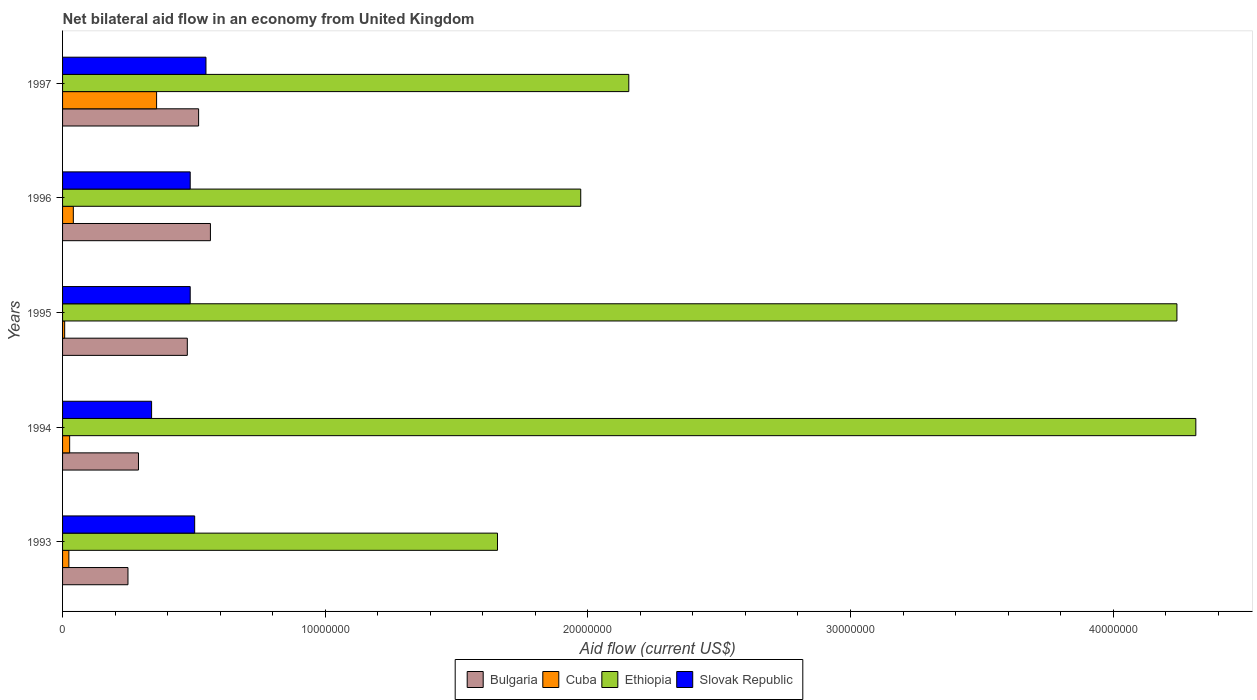How many different coloured bars are there?
Provide a short and direct response. 4. How many groups of bars are there?
Provide a succinct answer. 5. In how many cases, is the number of bars for a given year not equal to the number of legend labels?
Offer a terse response. 0. What is the net bilateral aid flow in Bulgaria in 1994?
Keep it short and to the point. 2.89e+06. Across all years, what is the maximum net bilateral aid flow in Bulgaria?
Offer a terse response. 5.63e+06. Across all years, what is the minimum net bilateral aid flow in Slovak Republic?
Make the answer very short. 3.39e+06. In which year was the net bilateral aid flow in Slovak Republic maximum?
Make the answer very short. 1997. In which year was the net bilateral aid flow in Bulgaria minimum?
Ensure brevity in your answer.  1993. What is the total net bilateral aid flow in Cuba in the graph?
Make the answer very short. 4.58e+06. What is the difference between the net bilateral aid flow in Ethiopia in 1995 and that in 1997?
Offer a very short reply. 2.09e+07. What is the difference between the net bilateral aid flow in Cuba in 1997 and the net bilateral aid flow in Slovak Republic in 1995?
Offer a terse response. -1.28e+06. What is the average net bilateral aid flow in Slovak Republic per year?
Your answer should be very brief. 4.72e+06. In the year 1996, what is the difference between the net bilateral aid flow in Ethiopia and net bilateral aid flow in Cuba?
Provide a succinct answer. 1.93e+07. In how many years, is the net bilateral aid flow in Cuba greater than 36000000 US$?
Offer a very short reply. 0. What is the ratio of the net bilateral aid flow in Ethiopia in 1994 to that in 1997?
Your answer should be very brief. 2. Is the difference between the net bilateral aid flow in Ethiopia in 1994 and 1997 greater than the difference between the net bilateral aid flow in Cuba in 1994 and 1997?
Provide a succinct answer. Yes. What is the difference between the highest and the second highest net bilateral aid flow in Cuba?
Offer a very short reply. 3.17e+06. What is the difference between the highest and the lowest net bilateral aid flow in Slovak Republic?
Your answer should be compact. 2.07e+06. In how many years, is the net bilateral aid flow in Bulgaria greater than the average net bilateral aid flow in Bulgaria taken over all years?
Make the answer very short. 3. What does the 3rd bar from the top in 1993 represents?
Ensure brevity in your answer.  Cuba. What does the 4th bar from the bottom in 1995 represents?
Provide a succinct answer. Slovak Republic. Is it the case that in every year, the sum of the net bilateral aid flow in Cuba and net bilateral aid flow in Bulgaria is greater than the net bilateral aid flow in Ethiopia?
Your answer should be compact. No. Are all the bars in the graph horizontal?
Keep it short and to the point. Yes. How many years are there in the graph?
Keep it short and to the point. 5. What is the difference between two consecutive major ticks on the X-axis?
Provide a short and direct response. 1.00e+07. Does the graph contain grids?
Give a very brief answer. No. Where does the legend appear in the graph?
Your answer should be compact. Bottom center. What is the title of the graph?
Provide a short and direct response. Net bilateral aid flow in an economy from United Kingdom. Does "East Asia (developing only)" appear as one of the legend labels in the graph?
Keep it short and to the point. No. What is the label or title of the X-axis?
Provide a short and direct response. Aid flow (current US$). What is the Aid flow (current US$) of Bulgaria in 1993?
Give a very brief answer. 2.49e+06. What is the Aid flow (current US$) of Ethiopia in 1993?
Offer a terse response. 1.66e+07. What is the Aid flow (current US$) of Slovak Republic in 1993?
Give a very brief answer. 5.03e+06. What is the Aid flow (current US$) of Bulgaria in 1994?
Ensure brevity in your answer.  2.89e+06. What is the Aid flow (current US$) of Ethiopia in 1994?
Offer a terse response. 4.32e+07. What is the Aid flow (current US$) in Slovak Republic in 1994?
Provide a short and direct response. 3.39e+06. What is the Aid flow (current US$) of Bulgaria in 1995?
Offer a terse response. 4.75e+06. What is the Aid flow (current US$) of Ethiopia in 1995?
Your response must be concise. 4.24e+07. What is the Aid flow (current US$) in Slovak Republic in 1995?
Provide a short and direct response. 4.86e+06. What is the Aid flow (current US$) in Bulgaria in 1996?
Provide a succinct answer. 5.63e+06. What is the Aid flow (current US$) in Ethiopia in 1996?
Your answer should be very brief. 1.97e+07. What is the Aid flow (current US$) in Slovak Republic in 1996?
Offer a very short reply. 4.86e+06. What is the Aid flow (current US$) in Bulgaria in 1997?
Give a very brief answer. 5.18e+06. What is the Aid flow (current US$) in Cuba in 1997?
Ensure brevity in your answer.  3.58e+06. What is the Aid flow (current US$) in Ethiopia in 1997?
Provide a succinct answer. 2.16e+07. What is the Aid flow (current US$) in Slovak Republic in 1997?
Your response must be concise. 5.46e+06. Across all years, what is the maximum Aid flow (current US$) in Bulgaria?
Offer a very short reply. 5.63e+06. Across all years, what is the maximum Aid flow (current US$) of Cuba?
Offer a very short reply. 3.58e+06. Across all years, what is the maximum Aid flow (current US$) of Ethiopia?
Make the answer very short. 4.32e+07. Across all years, what is the maximum Aid flow (current US$) in Slovak Republic?
Keep it short and to the point. 5.46e+06. Across all years, what is the minimum Aid flow (current US$) in Bulgaria?
Keep it short and to the point. 2.49e+06. Across all years, what is the minimum Aid flow (current US$) of Cuba?
Your answer should be compact. 8.00e+04. Across all years, what is the minimum Aid flow (current US$) in Ethiopia?
Your answer should be compact. 1.66e+07. Across all years, what is the minimum Aid flow (current US$) of Slovak Republic?
Provide a short and direct response. 3.39e+06. What is the total Aid flow (current US$) of Bulgaria in the graph?
Give a very brief answer. 2.09e+07. What is the total Aid flow (current US$) in Cuba in the graph?
Your answer should be compact. 4.58e+06. What is the total Aid flow (current US$) of Ethiopia in the graph?
Give a very brief answer. 1.43e+08. What is the total Aid flow (current US$) in Slovak Republic in the graph?
Give a very brief answer. 2.36e+07. What is the difference between the Aid flow (current US$) in Bulgaria in 1993 and that in 1994?
Your response must be concise. -4.00e+05. What is the difference between the Aid flow (current US$) in Ethiopia in 1993 and that in 1994?
Keep it short and to the point. -2.66e+07. What is the difference between the Aid flow (current US$) in Slovak Republic in 1993 and that in 1994?
Offer a very short reply. 1.64e+06. What is the difference between the Aid flow (current US$) in Bulgaria in 1993 and that in 1995?
Ensure brevity in your answer.  -2.26e+06. What is the difference between the Aid flow (current US$) of Ethiopia in 1993 and that in 1995?
Give a very brief answer. -2.59e+07. What is the difference between the Aid flow (current US$) in Slovak Republic in 1993 and that in 1995?
Your response must be concise. 1.70e+05. What is the difference between the Aid flow (current US$) in Bulgaria in 1993 and that in 1996?
Ensure brevity in your answer.  -3.14e+06. What is the difference between the Aid flow (current US$) of Ethiopia in 1993 and that in 1996?
Offer a very short reply. -3.17e+06. What is the difference between the Aid flow (current US$) of Bulgaria in 1993 and that in 1997?
Provide a succinct answer. -2.69e+06. What is the difference between the Aid flow (current US$) in Cuba in 1993 and that in 1997?
Provide a succinct answer. -3.34e+06. What is the difference between the Aid flow (current US$) of Ethiopia in 1993 and that in 1997?
Offer a very short reply. -5.00e+06. What is the difference between the Aid flow (current US$) of Slovak Republic in 1993 and that in 1997?
Your answer should be very brief. -4.30e+05. What is the difference between the Aid flow (current US$) in Bulgaria in 1994 and that in 1995?
Keep it short and to the point. -1.86e+06. What is the difference between the Aid flow (current US$) of Cuba in 1994 and that in 1995?
Provide a short and direct response. 1.90e+05. What is the difference between the Aid flow (current US$) of Ethiopia in 1994 and that in 1995?
Give a very brief answer. 7.20e+05. What is the difference between the Aid flow (current US$) of Slovak Republic in 1994 and that in 1995?
Keep it short and to the point. -1.47e+06. What is the difference between the Aid flow (current US$) in Bulgaria in 1994 and that in 1996?
Keep it short and to the point. -2.74e+06. What is the difference between the Aid flow (current US$) of Cuba in 1994 and that in 1996?
Your answer should be compact. -1.40e+05. What is the difference between the Aid flow (current US$) of Ethiopia in 1994 and that in 1996?
Give a very brief answer. 2.34e+07. What is the difference between the Aid flow (current US$) in Slovak Republic in 1994 and that in 1996?
Your response must be concise. -1.47e+06. What is the difference between the Aid flow (current US$) of Bulgaria in 1994 and that in 1997?
Your response must be concise. -2.29e+06. What is the difference between the Aid flow (current US$) of Cuba in 1994 and that in 1997?
Offer a very short reply. -3.31e+06. What is the difference between the Aid flow (current US$) in Ethiopia in 1994 and that in 1997?
Keep it short and to the point. 2.16e+07. What is the difference between the Aid flow (current US$) of Slovak Republic in 1994 and that in 1997?
Ensure brevity in your answer.  -2.07e+06. What is the difference between the Aid flow (current US$) in Bulgaria in 1995 and that in 1996?
Provide a short and direct response. -8.80e+05. What is the difference between the Aid flow (current US$) in Cuba in 1995 and that in 1996?
Provide a succinct answer. -3.30e+05. What is the difference between the Aid flow (current US$) of Ethiopia in 1995 and that in 1996?
Your response must be concise. 2.27e+07. What is the difference between the Aid flow (current US$) of Bulgaria in 1995 and that in 1997?
Provide a short and direct response. -4.30e+05. What is the difference between the Aid flow (current US$) of Cuba in 1995 and that in 1997?
Provide a short and direct response. -3.50e+06. What is the difference between the Aid flow (current US$) of Ethiopia in 1995 and that in 1997?
Your response must be concise. 2.09e+07. What is the difference between the Aid flow (current US$) in Slovak Republic in 1995 and that in 1997?
Provide a short and direct response. -6.00e+05. What is the difference between the Aid flow (current US$) in Bulgaria in 1996 and that in 1997?
Offer a very short reply. 4.50e+05. What is the difference between the Aid flow (current US$) in Cuba in 1996 and that in 1997?
Your response must be concise. -3.17e+06. What is the difference between the Aid flow (current US$) of Ethiopia in 1996 and that in 1997?
Offer a very short reply. -1.83e+06. What is the difference between the Aid flow (current US$) in Slovak Republic in 1996 and that in 1997?
Offer a terse response. -6.00e+05. What is the difference between the Aid flow (current US$) in Bulgaria in 1993 and the Aid flow (current US$) in Cuba in 1994?
Give a very brief answer. 2.22e+06. What is the difference between the Aid flow (current US$) of Bulgaria in 1993 and the Aid flow (current US$) of Ethiopia in 1994?
Provide a short and direct response. -4.07e+07. What is the difference between the Aid flow (current US$) in Bulgaria in 1993 and the Aid flow (current US$) in Slovak Republic in 1994?
Your answer should be compact. -9.00e+05. What is the difference between the Aid flow (current US$) of Cuba in 1993 and the Aid flow (current US$) of Ethiopia in 1994?
Offer a terse response. -4.29e+07. What is the difference between the Aid flow (current US$) in Cuba in 1993 and the Aid flow (current US$) in Slovak Republic in 1994?
Offer a very short reply. -3.15e+06. What is the difference between the Aid flow (current US$) of Ethiopia in 1993 and the Aid flow (current US$) of Slovak Republic in 1994?
Offer a very short reply. 1.32e+07. What is the difference between the Aid flow (current US$) of Bulgaria in 1993 and the Aid flow (current US$) of Cuba in 1995?
Make the answer very short. 2.41e+06. What is the difference between the Aid flow (current US$) in Bulgaria in 1993 and the Aid flow (current US$) in Ethiopia in 1995?
Provide a succinct answer. -3.99e+07. What is the difference between the Aid flow (current US$) of Bulgaria in 1993 and the Aid flow (current US$) of Slovak Republic in 1995?
Your response must be concise. -2.37e+06. What is the difference between the Aid flow (current US$) of Cuba in 1993 and the Aid flow (current US$) of Ethiopia in 1995?
Offer a terse response. -4.22e+07. What is the difference between the Aid flow (current US$) in Cuba in 1993 and the Aid flow (current US$) in Slovak Republic in 1995?
Give a very brief answer. -4.62e+06. What is the difference between the Aid flow (current US$) in Ethiopia in 1993 and the Aid flow (current US$) in Slovak Republic in 1995?
Your response must be concise. 1.17e+07. What is the difference between the Aid flow (current US$) in Bulgaria in 1993 and the Aid flow (current US$) in Cuba in 1996?
Ensure brevity in your answer.  2.08e+06. What is the difference between the Aid flow (current US$) in Bulgaria in 1993 and the Aid flow (current US$) in Ethiopia in 1996?
Provide a short and direct response. -1.72e+07. What is the difference between the Aid flow (current US$) in Bulgaria in 1993 and the Aid flow (current US$) in Slovak Republic in 1996?
Your response must be concise. -2.37e+06. What is the difference between the Aid flow (current US$) of Cuba in 1993 and the Aid flow (current US$) of Ethiopia in 1996?
Your answer should be compact. -1.95e+07. What is the difference between the Aid flow (current US$) in Cuba in 1993 and the Aid flow (current US$) in Slovak Republic in 1996?
Provide a short and direct response. -4.62e+06. What is the difference between the Aid flow (current US$) of Ethiopia in 1993 and the Aid flow (current US$) of Slovak Republic in 1996?
Make the answer very short. 1.17e+07. What is the difference between the Aid flow (current US$) in Bulgaria in 1993 and the Aid flow (current US$) in Cuba in 1997?
Provide a succinct answer. -1.09e+06. What is the difference between the Aid flow (current US$) in Bulgaria in 1993 and the Aid flow (current US$) in Ethiopia in 1997?
Your answer should be compact. -1.91e+07. What is the difference between the Aid flow (current US$) of Bulgaria in 1993 and the Aid flow (current US$) of Slovak Republic in 1997?
Provide a succinct answer. -2.97e+06. What is the difference between the Aid flow (current US$) of Cuba in 1993 and the Aid flow (current US$) of Ethiopia in 1997?
Your answer should be compact. -2.13e+07. What is the difference between the Aid flow (current US$) of Cuba in 1993 and the Aid flow (current US$) of Slovak Republic in 1997?
Your answer should be compact. -5.22e+06. What is the difference between the Aid flow (current US$) of Ethiopia in 1993 and the Aid flow (current US$) of Slovak Republic in 1997?
Offer a very short reply. 1.11e+07. What is the difference between the Aid flow (current US$) in Bulgaria in 1994 and the Aid flow (current US$) in Cuba in 1995?
Offer a very short reply. 2.81e+06. What is the difference between the Aid flow (current US$) of Bulgaria in 1994 and the Aid flow (current US$) of Ethiopia in 1995?
Provide a succinct answer. -3.95e+07. What is the difference between the Aid flow (current US$) of Bulgaria in 1994 and the Aid flow (current US$) of Slovak Republic in 1995?
Ensure brevity in your answer.  -1.97e+06. What is the difference between the Aid flow (current US$) of Cuba in 1994 and the Aid flow (current US$) of Ethiopia in 1995?
Make the answer very short. -4.22e+07. What is the difference between the Aid flow (current US$) in Cuba in 1994 and the Aid flow (current US$) in Slovak Republic in 1995?
Offer a terse response. -4.59e+06. What is the difference between the Aid flow (current US$) of Ethiopia in 1994 and the Aid flow (current US$) of Slovak Republic in 1995?
Your response must be concise. 3.83e+07. What is the difference between the Aid flow (current US$) in Bulgaria in 1994 and the Aid flow (current US$) in Cuba in 1996?
Provide a succinct answer. 2.48e+06. What is the difference between the Aid flow (current US$) of Bulgaria in 1994 and the Aid flow (current US$) of Ethiopia in 1996?
Make the answer very short. -1.68e+07. What is the difference between the Aid flow (current US$) in Bulgaria in 1994 and the Aid flow (current US$) in Slovak Republic in 1996?
Provide a short and direct response. -1.97e+06. What is the difference between the Aid flow (current US$) in Cuba in 1994 and the Aid flow (current US$) in Ethiopia in 1996?
Ensure brevity in your answer.  -1.95e+07. What is the difference between the Aid flow (current US$) in Cuba in 1994 and the Aid flow (current US$) in Slovak Republic in 1996?
Your answer should be very brief. -4.59e+06. What is the difference between the Aid flow (current US$) in Ethiopia in 1994 and the Aid flow (current US$) in Slovak Republic in 1996?
Ensure brevity in your answer.  3.83e+07. What is the difference between the Aid flow (current US$) in Bulgaria in 1994 and the Aid flow (current US$) in Cuba in 1997?
Provide a short and direct response. -6.90e+05. What is the difference between the Aid flow (current US$) in Bulgaria in 1994 and the Aid flow (current US$) in Ethiopia in 1997?
Provide a succinct answer. -1.87e+07. What is the difference between the Aid flow (current US$) in Bulgaria in 1994 and the Aid flow (current US$) in Slovak Republic in 1997?
Your answer should be compact. -2.57e+06. What is the difference between the Aid flow (current US$) in Cuba in 1994 and the Aid flow (current US$) in Ethiopia in 1997?
Provide a succinct answer. -2.13e+07. What is the difference between the Aid flow (current US$) of Cuba in 1994 and the Aid flow (current US$) of Slovak Republic in 1997?
Your response must be concise. -5.19e+06. What is the difference between the Aid flow (current US$) in Ethiopia in 1994 and the Aid flow (current US$) in Slovak Republic in 1997?
Make the answer very short. 3.77e+07. What is the difference between the Aid flow (current US$) in Bulgaria in 1995 and the Aid flow (current US$) in Cuba in 1996?
Offer a terse response. 4.34e+06. What is the difference between the Aid flow (current US$) of Bulgaria in 1995 and the Aid flow (current US$) of Ethiopia in 1996?
Your answer should be very brief. -1.50e+07. What is the difference between the Aid flow (current US$) in Bulgaria in 1995 and the Aid flow (current US$) in Slovak Republic in 1996?
Provide a succinct answer. -1.10e+05. What is the difference between the Aid flow (current US$) in Cuba in 1995 and the Aid flow (current US$) in Ethiopia in 1996?
Ensure brevity in your answer.  -1.96e+07. What is the difference between the Aid flow (current US$) in Cuba in 1995 and the Aid flow (current US$) in Slovak Republic in 1996?
Give a very brief answer. -4.78e+06. What is the difference between the Aid flow (current US$) in Ethiopia in 1995 and the Aid flow (current US$) in Slovak Republic in 1996?
Offer a very short reply. 3.76e+07. What is the difference between the Aid flow (current US$) in Bulgaria in 1995 and the Aid flow (current US$) in Cuba in 1997?
Your answer should be very brief. 1.17e+06. What is the difference between the Aid flow (current US$) in Bulgaria in 1995 and the Aid flow (current US$) in Ethiopia in 1997?
Make the answer very short. -1.68e+07. What is the difference between the Aid flow (current US$) of Bulgaria in 1995 and the Aid flow (current US$) of Slovak Republic in 1997?
Give a very brief answer. -7.10e+05. What is the difference between the Aid flow (current US$) of Cuba in 1995 and the Aid flow (current US$) of Ethiopia in 1997?
Offer a very short reply. -2.15e+07. What is the difference between the Aid flow (current US$) of Cuba in 1995 and the Aid flow (current US$) of Slovak Republic in 1997?
Give a very brief answer. -5.38e+06. What is the difference between the Aid flow (current US$) in Ethiopia in 1995 and the Aid flow (current US$) in Slovak Republic in 1997?
Keep it short and to the point. 3.70e+07. What is the difference between the Aid flow (current US$) in Bulgaria in 1996 and the Aid flow (current US$) in Cuba in 1997?
Ensure brevity in your answer.  2.05e+06. What is the difference between the Aid flow (current US$) in Bulgaria in 1996 and the Aid flow (current US$) in Ethiopia in 1997?
Make the answer very short. -1.59e+07. What is the difference between the Aid flow (current US$) in Cuba in 1996 and the Aid flow (current US$) in Ethiopia in 1997?
Your answer should be compact. -2.12e+07. What is the difference between the Aid flow (current US$) of Cuba in 1996 and the Aid flow (current US$) of Slovak Republic in 1997?
Your answer should be very brief. -5.05e+06. What is the difference between the Aid flow (current US$) of Ethiopia in 1996 and the Aid flow (current US$) of Slovak Republic in 1997?
Offer a terse response. 1.43e+07. What is the average Aid flow (current US$) in Bulgaria per year?
Your response must be concise. 4.19e+06. What is the average Aid flow (current US$) of Cuba per year?
Keep it short and to the point. 9.16e+05. What is the average Aid flow (current US$) in Ethiopia per year?
Keep it short and to the point. 2.87e+07. What is the average Aid flow (current US$) in Slovak Republic per year?
Provide a short and direct response. 4.72e+06. In the year 1993, what is the difference between the Aid flow (current US$) in Bulgaria and Aid flow (current US$) in Cuba?
Give a very brief answer. 2.25e+06. In the year 1993, what is the difference between the Aid flow (current US$) of Bulgaria and Aid flow (current US$) of Ethiopia?
Offer a terse response. -1.41e+07. In the year 1993, what is the difference between the Aid flow (current US$) in Bulgaria and Aid flow (current US$) in Slovak Republic?
Provide a short and direct response. -2.54e+06. In the year 1993, what is the difference between the Aid flow (current US$) in Cuba and Aid flow (current US$) in Ethiopia?
Make the answer very short. -1.63e+07. In the year 1993, what is the difference between the Aid flow (current US$) in Cuba and Aid flow (current US$) in Slovak Republic?
Give a very brief answer. -4.79e+06. In the year 1993, what is the difference between the Aid flow (current US$) in Ethiopia and Aid flow (current US$) in Slovak Republic?
Provide a short and direct response. 1.15e+07. In the year 1994, what is the difference between the Aid flow (current US$) in Bulgaria and Aid flow (current US$) in Cuba?
Your answer should be very brief. 2.62e+06. In the year 1994, what is the difference between the Aid flow (current US$) of Bulgaria and Aid flow (current US$) of Ethiopia?
Ensure brevity in your answer.  -4.03e+07. In the year 1994, what is the difference between the Aid flow (current US$) of Bulgaria and Aid flow (current US$) of Slovak Republic?
Give a very brief answer. -5.00e+05. In the year 1994, what is the difference between the Aid flow (current US$) in Cuba and Aid flow (current US$) in Ethiopia?
Provide a succinct answer. -4.29e+07. In the year 1994, what is the difference between the Aid flow (current US$) of Cuba and Aid flow (current US$) of Slovak Republic?
Offer a very short reply. -3.12e+06. In the year 1994, what is the difference between the Aid flow (current US$) of Ethiopia and Aid flow (current US$) of Slovak Republic?
Your answer should be very brief. 3.98e+07. In the year 1995, what is the difference between the Aid flow (current US$) in Bulgaria and Aid flow (current US$) in Cuba?
Ensure brevity in your answer.  4.67e+06. In the year 1995, what is the difference between the Aid flow (current US$) in Bulgaria and Aid flow (current US$) in Ethiopia?
Make the answer very short. -3.77e+07. In the year 1995, what is the difference between the Aid flow (current US$) in Bulgaria and Aid flow (current US$) in Slovak Republic?
Offer a terse response. -1.10e+05. In the year 1995, what is the difference between the Aid flow (current US$) in Cuba and Aid flow (current US$) in Ethiopia?
Keep it short and to the point. -4.24e+07. In the year 1995, what is the difference between the Aid flow (current US$) in Cuba and Aid flow (current US$) in Slovak Republic?
Keep it short and to the point. -4.78e+06. In the year 1995, what is the difference between the Aid flow (current US$) of Ethiopia and Aid flow (current US$) of Slovak Republic?
Your answer should be very brief. 3.76e+07. In the year 1996, what is the difference between the Aid flow (current US$) of Bulgaria and Aid flow (current US$) of Cuba?
Offer a terse response. 5.22e+06. In the year 1996, what is the difference between the Aid flow (current US$) of Bulgaria and Aid flow (current US$) of Ethiopia?
Offer a very short reply. -1.41e+07. In the year 1996, what is the difference between the Aid flow (current US$) of Bulgaria and Aid flow (current US$) of Slovak Republic?
Your answer should be very brief. 7.70e+05. In the year 1996, what is the difference between the Aid flow (current US$) of Cuba and Aid flow (current US$) of Ethiopia?
Your answer should be very brief. -1.93e+07. In the year 1996, what is the difference between the Aid flow (current US$) in Cuba and Aid flow (current US$) in Slovak Republic?
Your answer should be compact. -4.45e+06. In the year 1996, what is the difference between the Aid flow (current US$) of Ethiopia and Aid flow (current US$) of Slovak Republic?
Make the answer very short. 1.49e+07. In the year 1997, what is the difference between the Aid flow (current US$) in Bulgaria and Aid flow (current US$) in Cuba?
Your answer should be compact. 1.60e+06. In the year 1997, what is the difference between the Aid flow (current US$) of Bulgaria and Aid flow (current US$) of Ethiopia?
Offer a terse response. -1.64e+07. In the year 1997, what is the difference between the Aid flow (current US$) in Bulgaria and Aid flow (current US$) in Slovak Republic?
Your answer should be very brief. -2.80e+05. In the year 1997, what is the difference between the Aid flow (current US$) of Cuba and Aid flow (current US$) of Ethiopia?
Provide a short and direct response. -1.80e+07. In the year 1997, what is the difference between the Aid flow (current US$) in Cuba and Aid flow (current US$) in Slovak Republic?
Make the answer very short. -1.88e+06. In the year 1997, what is the difference between the Aid flow (current US$) of Ethiopia and Aid flow (current US$) of Slovak Republic?
Offer a terse response. 1.61e+07. What is the ratio of the Aid flow (current US$) in Bulgaria in 1993 to that in 1994?
Offer a terse response. 0.86. What is the ratio of the Aid flow (current US$) of Ethiopia in 1993 to that in 1994?
Keep it short and to the point. 0.38. What is the ratio of the Aid flow (current US$) of Slovak Republic in 1993 to that in 1994?
Your response must be concise. 1.48. What is the ratio of the Aid flow (current US$) in Bulgaria in 1993 to that in 1995?
Your answer should be compact. 0.52. What is the ratio of the Aid flow (current US$) in Cuba in 1993 to that in 1995?
Keep it short and to the point. 3. What is the ratio of the Aid flow (current US$) in Ethiopia in 1993 to that in 1995?
Provide a short and direct response. 0.39. What is the ratio of the Aid flow (current US$) in Slovak Republic in 1993 to that in 1995?
Make the answer very short. 1.03. What is the ratio of the Aid flow (current US$) in Bulgaria in 1993 to that in 1996?
Give a very brief answer. 0.44. What is the ratio of the Aid flow (current US$) in Cuba in 1993 to that in 1996?
Offer a terse response. 0.59. What is the ratio of the Aid flow (current US$) in Ethiopia in 1993 to that in 1996?
Make the answer very short. 0.84. What is the ratio of the Aid flow (current US$) of Slovak Republic in 1993 to that in 1996?
Your answer should be compact. 1.03. What is the ratio of the Aid flow (current US$) in Bulgaria in 1993 to that in 1997?
Provide a short and direct response. 0.48. What is the ratio of the Aid flow (current US$) in Cuba in 1993 to that in 1997?
Provide a short and direct response. 0.07. What is the ratio of the Aid flow (current US$) in Ethiopia in 1993 to that in 1997?
Your answer should be very brief. 0.77. What is the ratio of the Aid flow (current US$) of Slovak Republic in 1993 to that in 1997?
Give a very brief answer. 0.92. What is the ratio of the Aid flow (current US$) of Bulgaria in 1994 to that in 1995?
Your answer should be compact. 0.61. What is the ratio of the Aid flow (current US$) of Cuba in 1994 to that in 1995?
Your answer should be very brief. 3.38. What is the ratio of the Aid flow (current US$) of Slovak Republic in 1994 to that in 1995?
Your answer should be very brief. 0.7. What is the ratio of the Aid flow (current US$) of Bulgaria in 1994 to that in 1996?
Your response must be concise. 0.51. What is the ratio of the Aid flow (current US$) in Cuba in 1994 to that in 1996?
Ensure brevity in your answer.  0.66. What is the ratio of the Aid flow (current US$) in Ethiopia in 1994 to that in 1996?
Offer a very short reply. 2.19. What is the ratio of the Aid flow (current US$) of Slovak Republic in 1994 to that in 1996?
Keep it short and to the point. 0.7. What is the ratio of the Aid flow (current US$) in Bulgaria in 1994 to that in 1997?
Offer a very short reply. 0.56. What is the ratio of the Aid flow (current US$) in Cuba in 1994 to that in 1997?
Make the answer very short. 0.08. What is the ratio of the Aid flow (current US$) in Ethiopia in 1994 to that in 1997?
Ensure brevity in your answer.  2. What is the ratio of the Aid flow (current US$) in Slovak Republic in 1994 to that in 1997?
Offer a very short reply. 0.62. What is the ratio of the Aid flow (current US$) in Bulgaria in 1995 to that in 1996?
Make the answer very short. 0.84. What is the ratio of the Aid flow (current US$) in Cuba in 1995 to that in 1996?
Your answer should be very brief. 0.2. What is the ratio of the Aid flow (current US$) in Ethiopia in 1995 to that in 1996?
Give a very brief answer. 2.15. What is the ratio of the Aid flow (current US$) of Bulgaria in 1995 to that in 1997?
Give a very brief answer. 0.92. What is the ratio of the Aid flow (current US$) of Cuba in 1995 to that in 1997?
Your answer should be compact. 0.02. What is the ratio of the Aid flow (current US$) of Ethiopia in 1995 to that in 1997?
Make the answer very short. 1.97. What is the ratio of the Aid flow (current US$) in Slovak Republic in 1995 to that in 1997?
Make the answer very short. 0.89. What is the ratio of the Aid flow (current US$) of Bulgaria in 1996 to that in 1997?
Make the answer very short. 1.09. What is the ratio of the Aid flow (current US$) in Cuba in 1996 to that in 1997?
Your answer should be very brief. 0.11. What is the ratio of the Aid flow (current US$) of Ethiopia in 1996 to that in 1997?
Your response must be concise. 0.92. What is the ratio of the Aid flow (current US$) in Slovak Republic in 1996 to that in 1997?
Make the answer very short. 0.89. What is the difference between the highest and the second highest Aid flow (current US$) of Cuba?
Provide a succinct answer. 3.17e+06. What is the difference between the highest and the second highest Aid flow (current US$) of Ethiopia?
Provide a succinct answer. 7.20e+05. What is the difference between the highest and the lowest Aid flow (current US$) of Bulgaria?
Your response must be concise. 3.14e+06. What is the difference between the highest and the lowest Aid flow (current US$) of Cuba?
Your answer should be very brief. 3.50e+06. What is the difference between the highest and the lowest Aid flow (current US$) in Ethiopia?
Your response must be concise. 2.66e+07. What is the difference between the highest and the lowest Aid flow (current US$) in Slovak Republic?
Give a very brief answer. 2.07e+06. 